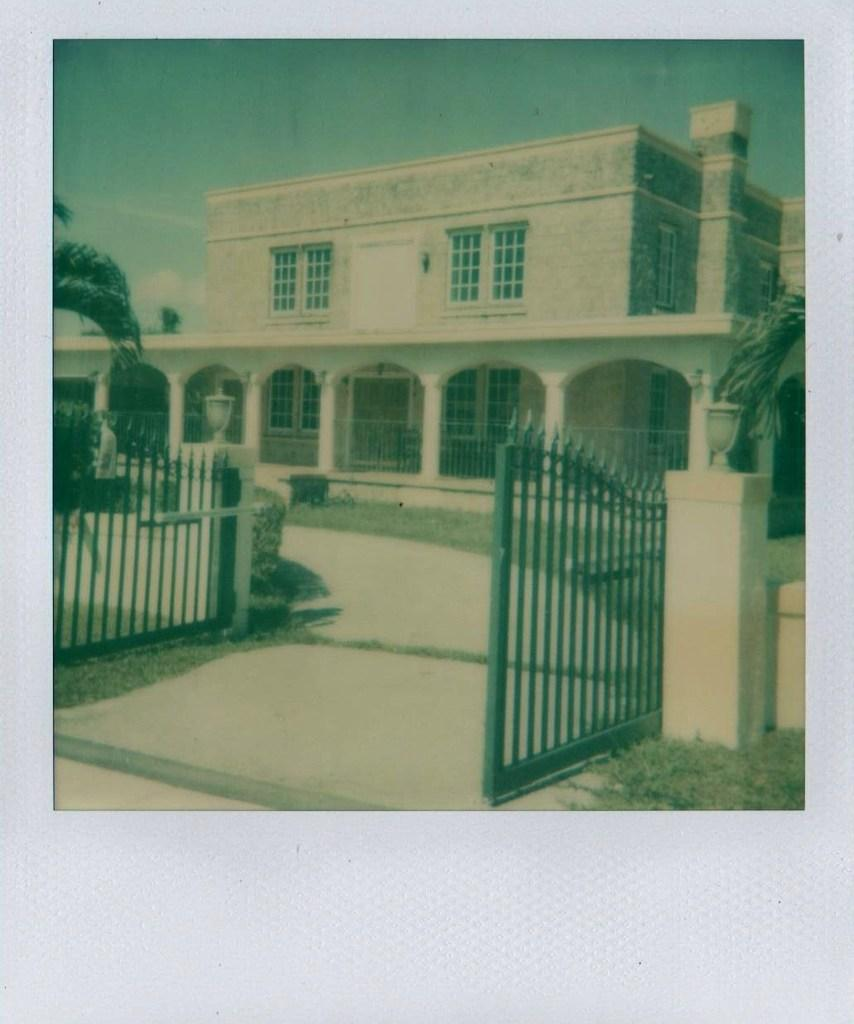What is the main structure in the center of the image? There is a building in the center of the image. What is the purpose of the entrance in the image? There is a gate in the image, which serves as an entrance. What type of vegetation can be seen in the image? There are plants and trees in the image. What is visible at the top of the image? The sky is visible at the top of the image. What type of verse is being recited by the tree in the image? There is no tree reciting any verse in the image; it is a static image of a building, gate, plants, trees, and sky. 